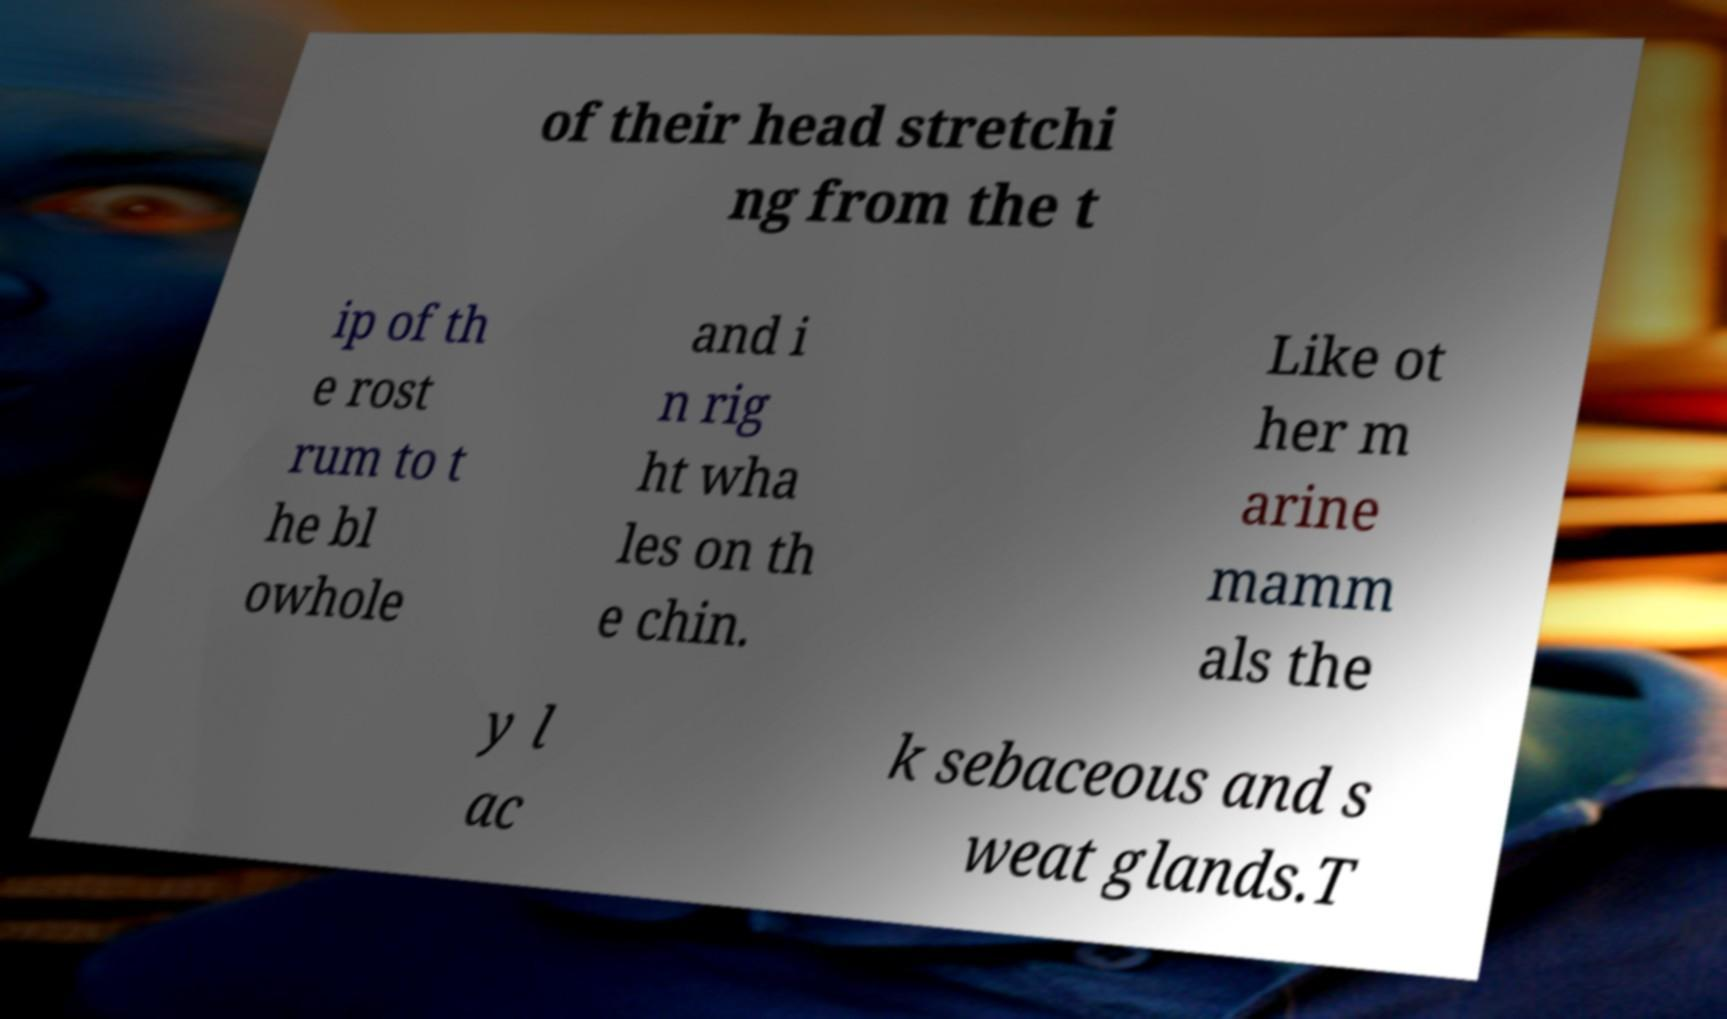Could you assist in decoding the text presented in this image and type it out clearly? of their head stretchi ng from the t ip of th e rost rum to t he bl owhole and i n rig ht wha les on th e chin. Like ot her m arine mamm als the y l ac k sebaceous and s weat glands.T 